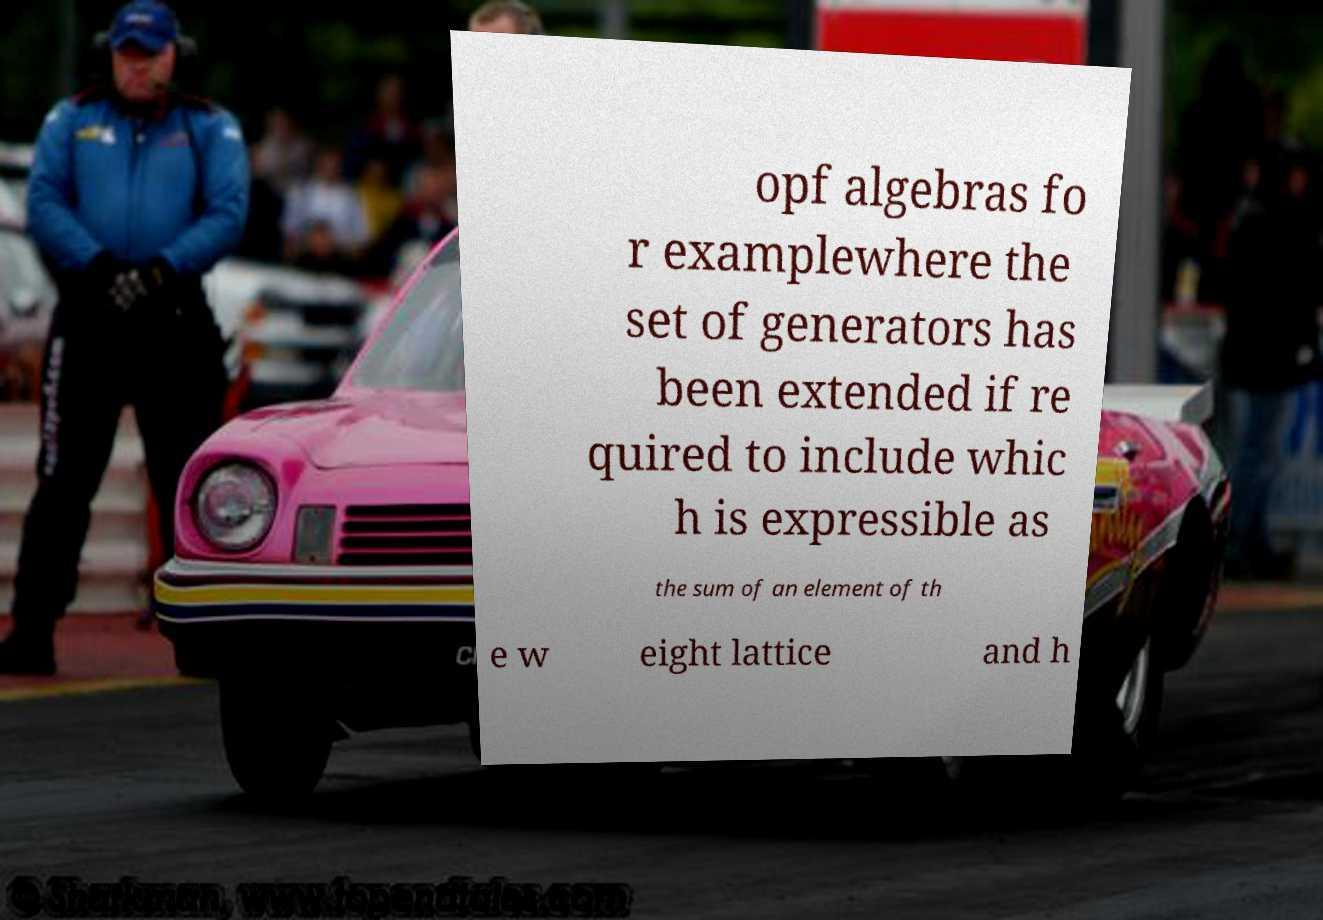There's text embedded in this image that I need extracted. Can you transcribe it verbatim? opf algebras fo r examplewhere the set of generators has been extended if re quired to include whic h is expressible as the sum of an element of th e w eight lattice and h 